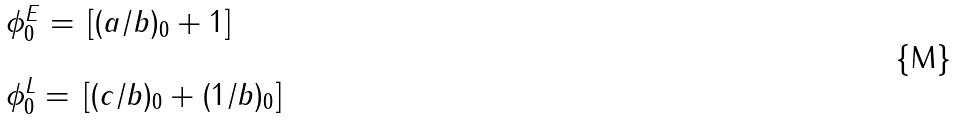<formula> <loc_0><loc_0><loc_500><loc_500>\begin{array} { l l } \phi ^ { E } _ { 0 } = \, [ ( a / b ) _ { 0 } + 1 ] \\ \\ \phi ^ { L } _ { 0 } = \, [ ( c / b ) _ { 0 } + ( 1 / b ) _ { 0 } ] \end{array}</formula> 